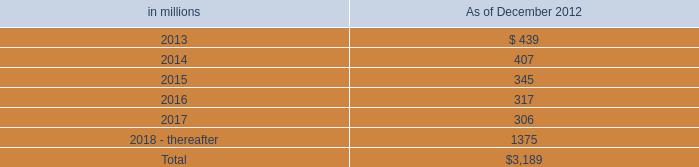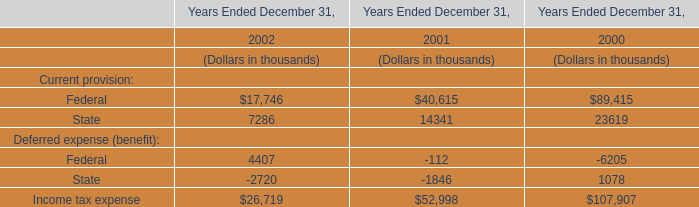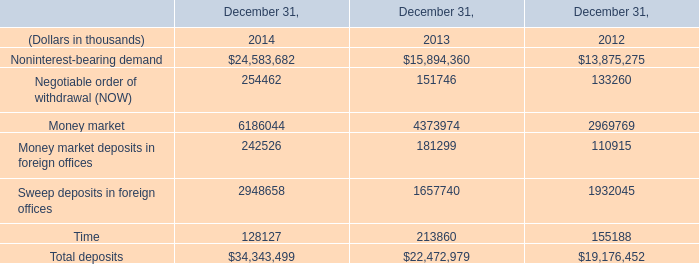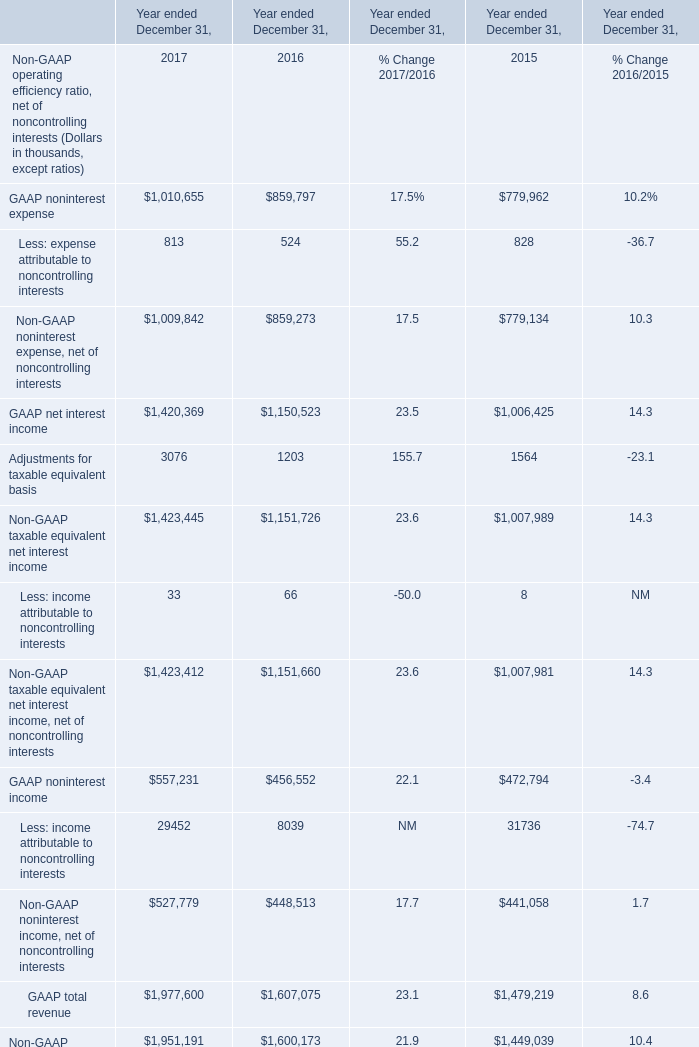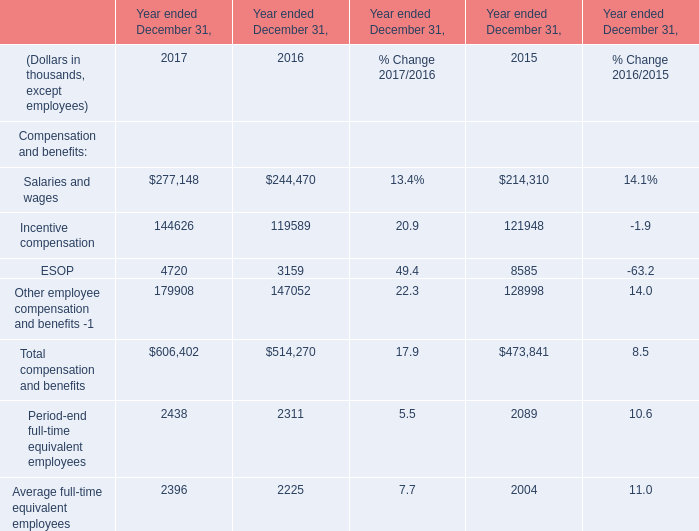In the year with lowest amount of ESOP, what's the increasing rate of Other employee compensation and benefits -1 ? 
Computations: ((179908 - 147052) / 147052)
Answer: 0.22343. 